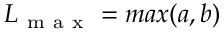Convert formula to latex. <formula><loc_0><loc_0><loc_500><loc_500>L _ { m a x } = \max ( a , b )</formula> 